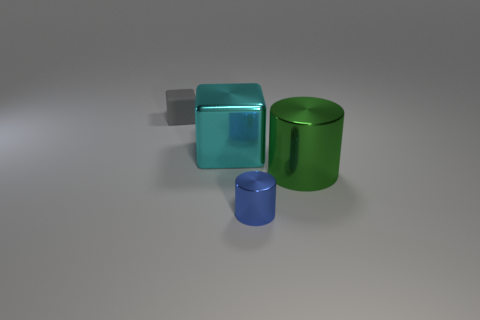Are the objects solid or hollow? The objects appear to be solid, but it's not possible to definitively determine from the image alone without additional context. What clues in the image lead you to believe they might be solid? The absence of visible openings or seams along with the consistent light reflections suggest the objects could be solid. 